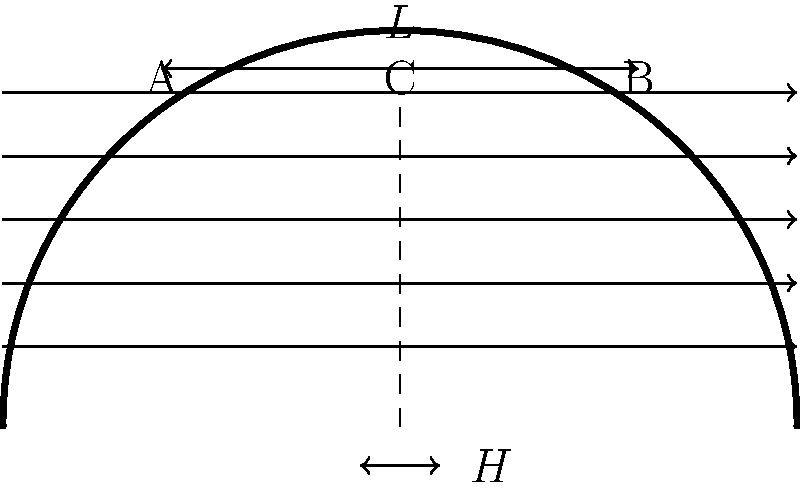As an aerodynamics engineer working on cricket helmet design for the Adelaide Strikers, you're tasked with optimizing the helmet's shape to reduce drag. The current design has a flat top section (AB) of length $L$ and height $H$ from the base. If the drag coefficient $C_d$ is given by the equation $C_d = 0.12 + \frac{0.3H}{L}$, what is the optimal ratio of $\frac{H}{L}$ to minimize drag while maintaining a minimum height of 12 cm for player protection? Assume the length $L$ is fixed at 60 cm. Let's approach this step-by-step:

1) The drag coefficient equation is given as:
   $C_d = 0.12 + \frac{0.3H}{L}$

2) We need to minimize $C_d$. Since 0.12 is constant, we need to minimize $\frac{0.3H}{L}$.

3) Given that $L$ is fixed at 60 cm, we can rewrite the equation as:
   $C_d = 0.12 + 0.005H$

4) Normally, to minimize this, we would set $H=0$. However, we have a constraint that $H$ must be at least 12 cm for player protection.

5) Since the drag coefficient increases linearly with $H$, and we want to minimize it, the optimal value for $H$ is the minimum allowed value, which is 12 cm.

6) Now, let's calculate the optimal ratio $\frac{H}{L}$:
   $\frac{H}{L} = \frac{12 \text{ cm}}{60 \text{ cm}} = 0.2$

Therefore, the optimal ratio of $\frac{H}{L}$ to minimize drag while meeting the safety requirement is 0.2 or 1:5.
Answer: 0.2 